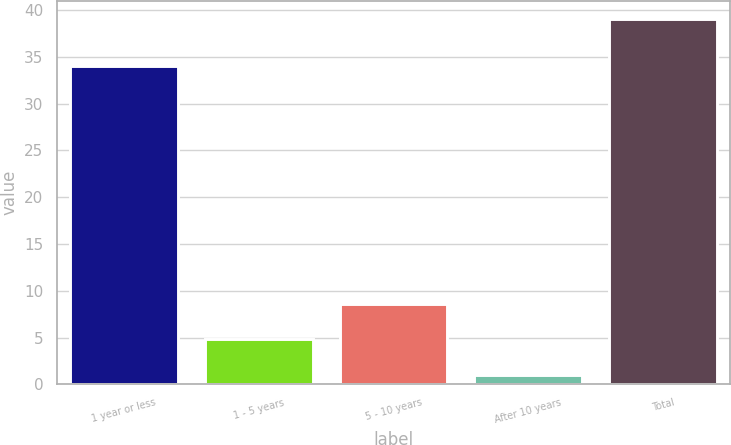Convert chart. <chart><loc_0><loc_0><loc_500><loc_500><bar_chart><fcel>1 year or less<fcel>1 - 5 years<fcel>5 - 10 years<fcel>After 10 years<fcel>Total<nl><fcel>34<fcel>4.8<fcel>8.6<fcel>1<fcel>39<nl></chart> 